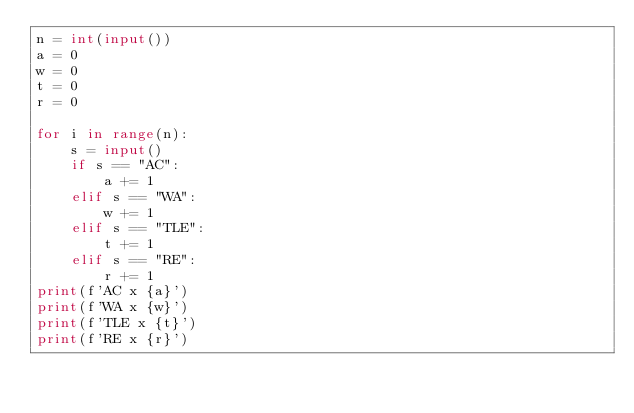Convert code to text. <code><loc_0><loc_0><loc_500><loc_500><_Python_>n = int(input())
a = 0
w = 0
t = 0
r = 0

for i in range(n):
    s = input()
    if s == "AC":
        a += 1
    elif s == "WA":
        w += 1
    elif s == "TLE":
        t += 1
    elif s == "RE":
        r += 1
print(f'AC x {a}')
print(f'WA x {w}')
print(f'TLE x {t}')
print(f'RE x {r}')





</code> 